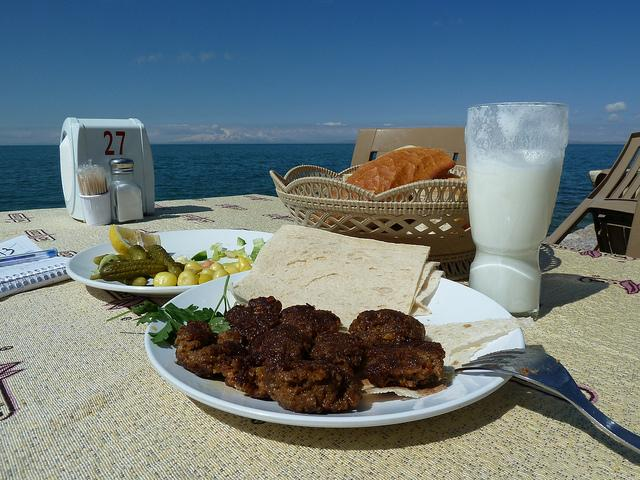Why would someone be seated here? to eat 